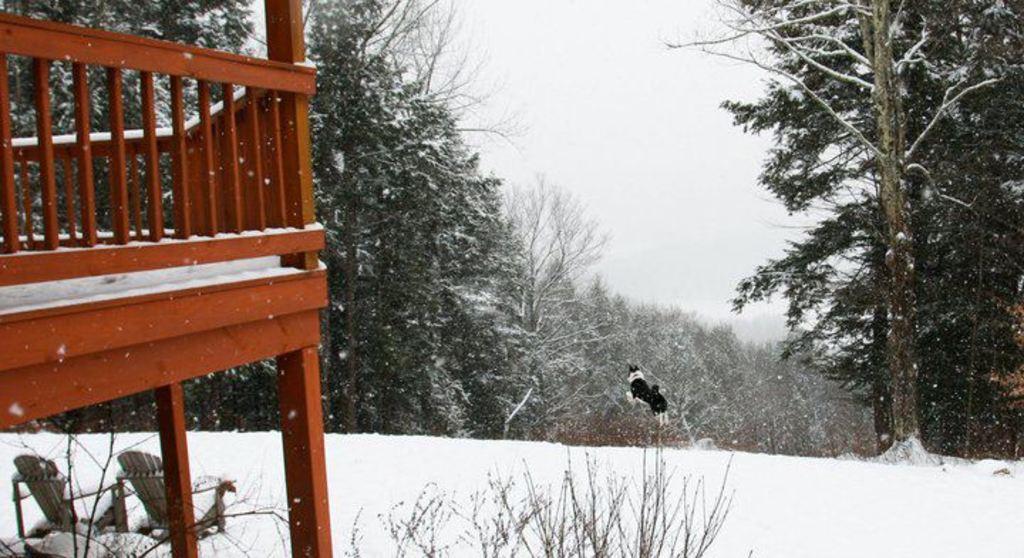Describe this image in one or two sentences. In the picture I can see a dog is jumping in the air. On the left side I can see chairs, wooden fence and plants. In the background I can see trees, the snow and the sky. 